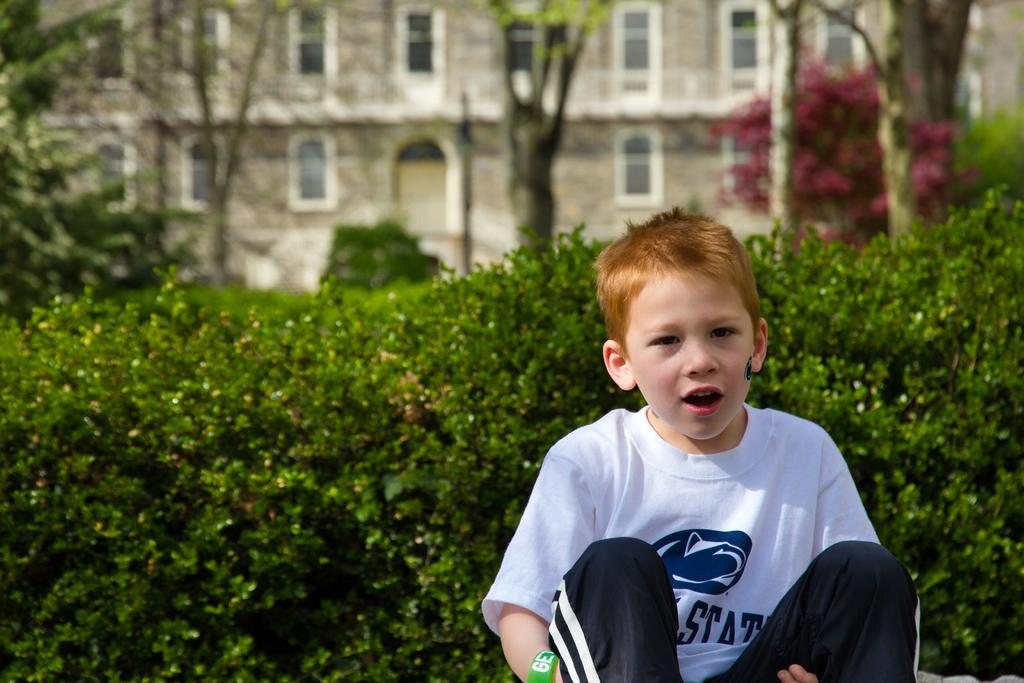<image>
Share a concise interpretation of the image provided. A boy in a white and blue shirt that is displaying the word Stat. 